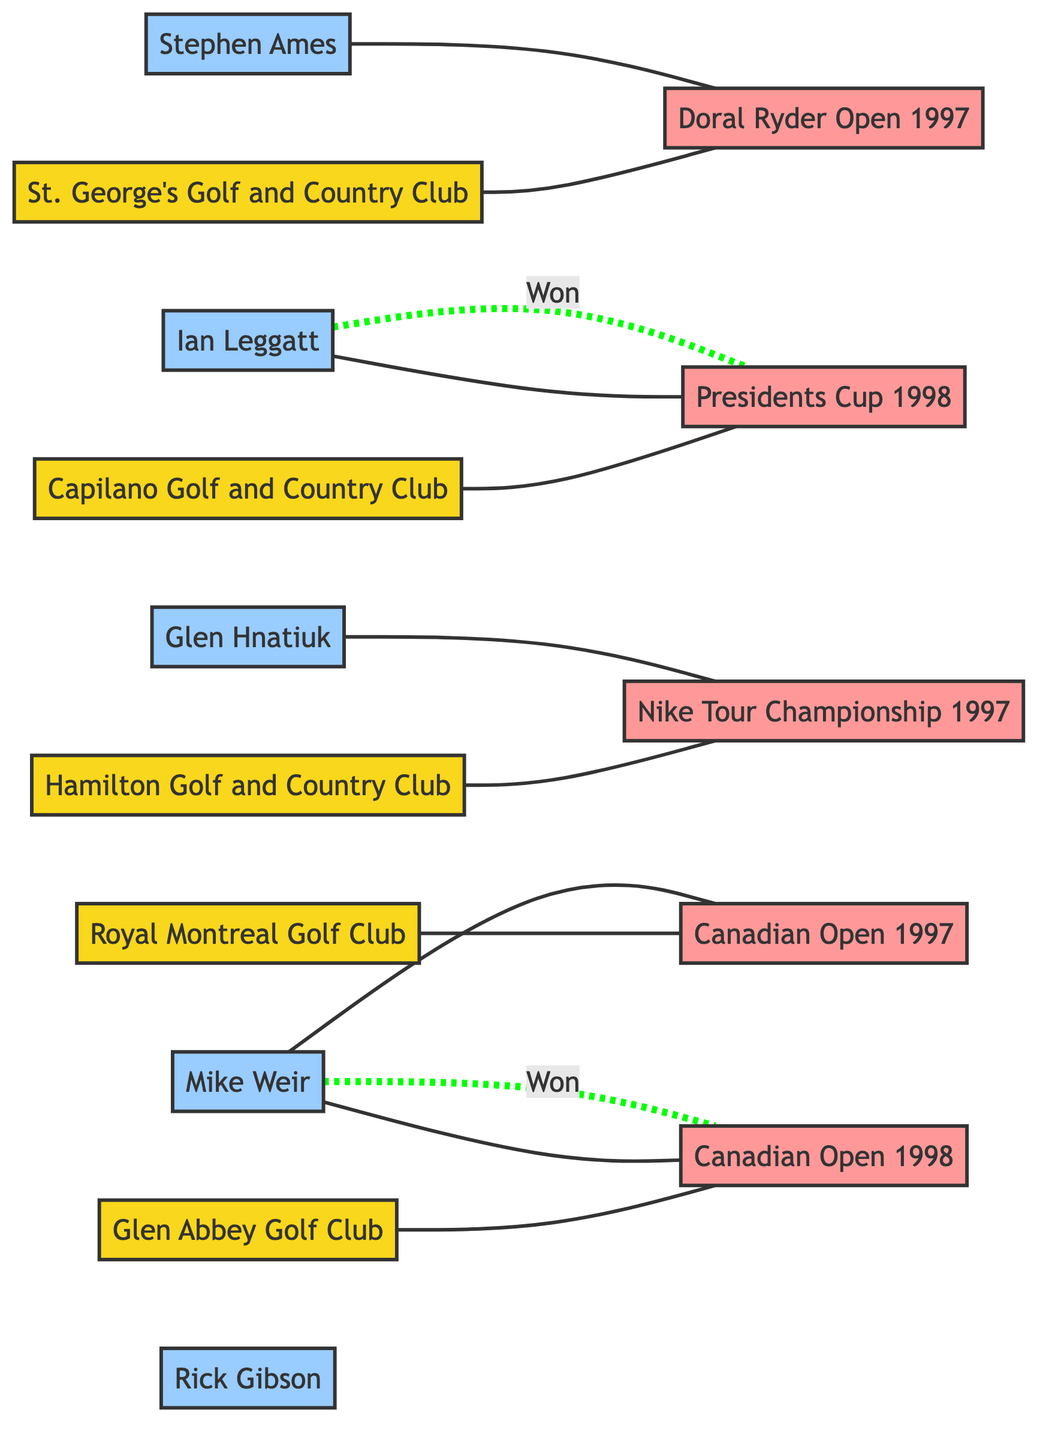What golf club hosted the Canadian Open in 1997? The diagram indicates that the Canadian Open in 1997 is connected to the Royal Montreal Golf Club. Therefore, the club that hosted this tournament is the Royal Montreal Golf Club.
Answer: Royal Montreal Golf Club How many tournaments are associated with Glen Abbey Golf Club? The diagram shows one connection from Glen Abbey Golf Club to the Canadian Open in 1998. Since there are no other connections, only one tournament is associated with Glen Abbey Golf Club.
Answer: 1 Who won the Presidents Cup in 1998? The diagram shows Ian Leggatt is connected to the Presidents Cup and is marked as having won that tournament. Therefore, the winner of the Presidents Cup in 1998 is Ian Leggatt.
Answer: Ian Leggatt Which player participated in the Doral Ryder Open in 1997? The diagram indicates that Stephen Ames is linked to the Doral Ryder Open tournament in 1997. Thus, the player who participated in this tournament is Stephen Ames.
Answer: Stephen Ames How many players participated in the Canadian Open in 1997? The diagram shows that between the node for the Canadian Open in 1997 and the players, there is one connection to Mike Weir. Therefore, only one player participated in the Canadian Open in 1997, which is Mike Weir.
Answer: 1 Which tournament did Hamilton Golf and Country Club host? The diagram connections indicate that Hamilton Golf and Country Club is linked to the Nike Tour Championship in 1997. Thus, the tournament hosted by Hamilton Golf and Country Club is the Nike Tour Championship.
Answer: Nike Tour Championship How many players won tournaments in 1998? The diagram indicates there are two victories, one by Mike Weir in the Canadian Open and one by Ian Leggatt in the Presidents Cup. Hence, two players won tournaments in 1998.
Answer: 2 Which player is not connected to any tournaments in this diagram? Upon reviewing the diagram, Rick Gibson has no connections to any tournaments, meaning he is not connected to any tournaments in the diagram.
Answer: Rick Gibson Which two tournaments are linked to the Royal Montreal Golf Club? The diagram shows a connection from the Royal Montreal Golf Club to only one tournament, the Canadian Open in 1997. Therefore, Royal Montreal Golf Club is not linked to any other tournaments.
Answer: 1 